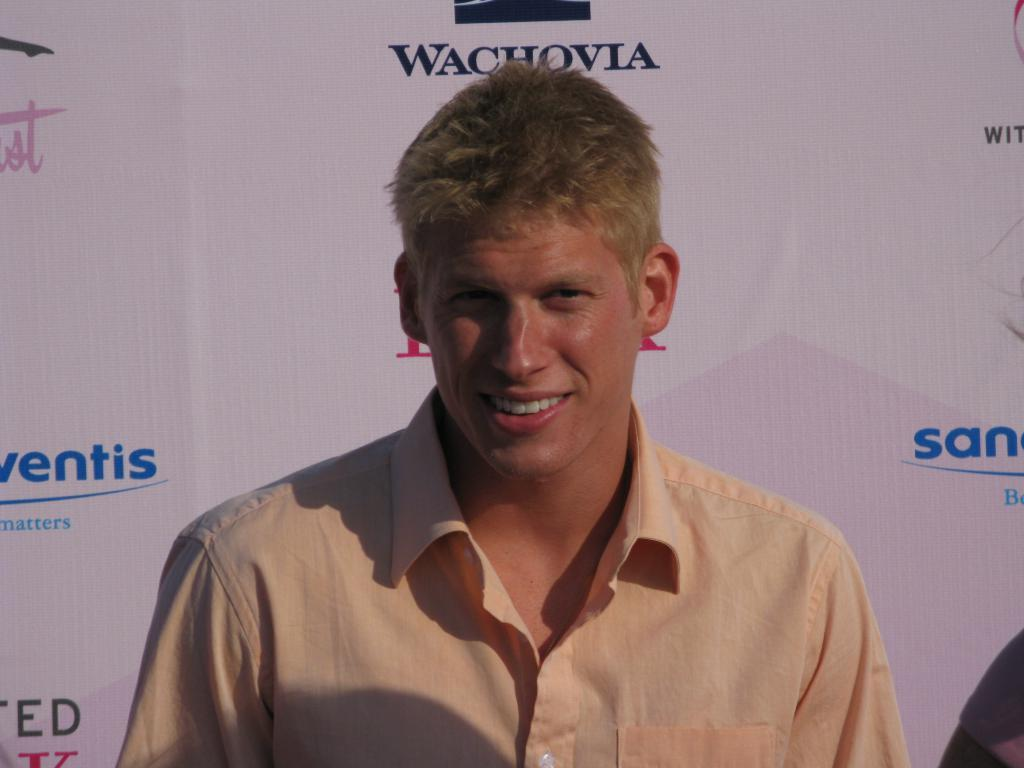Who is the main subject in the image? There is a man in the center of the image. What is the man doing in the image? The man is smiling. What can be seen in the background of the image? There is a banner in the background of the image. What is written on the banner? The banner has text written on it. What type of meat is being served at the downtown event in the image? There is no mention of meat or a downtown event in the image; it features a man smiling with a banner in the background. Are the people in the image wearing masks? There are no people wearing masks in the image; it only shows a man smiling and a banner in the background. 